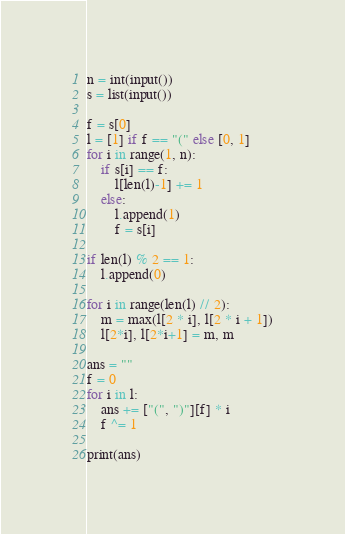Convert code to text. <code><loc_0><loc_0><loc_500><loc_500><_Python_>n = int(input())
s = list(input())

f = s[0]
l = [1] if f == "(" else [0, 1]
for i in range(1, n):
    if s[i] == f:
        l[len(l)-1] += 1
    else:
        l.append(1)
        f = s[i]

if len(l) % 2 == 1:
    l.append(0)

for i in range(len(l) // 2):
    m = max(l[2 * i], l[2 * i + 1])
    l[2*i], l[2*i+1] = m, m

ans = ""
f = 0
for i in l:
    ans += ["(", ")"][f] * i
    f ^= 1

print(ans)
</code> 